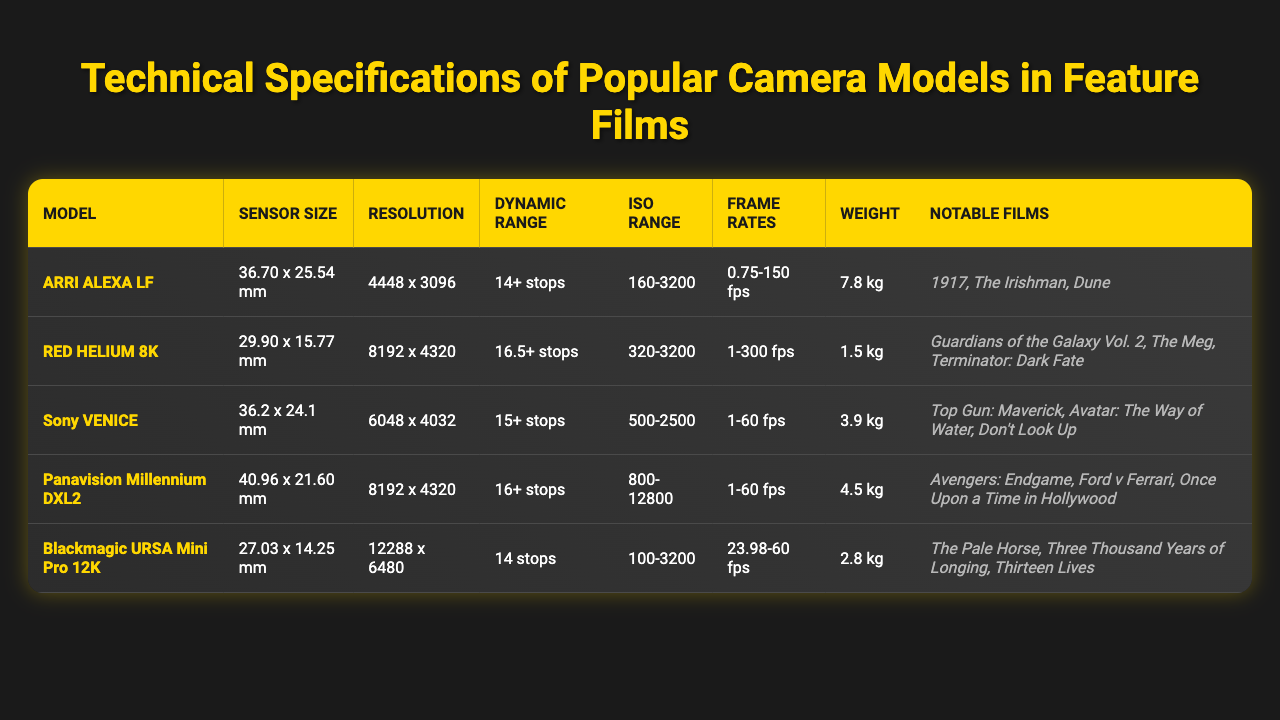What is the sensor size of the ARRI ALEXA LF? The table lists the ARRI ALEXA LF under the "Model" column and its corresponding "Sensor Size" is shown as 36.70 x 25.54 mm.
Answer: 36.70 x 25.54 mm Which camera has the highest resolution? By comparing the "Resolution" values, the RED HELIUM 8K has a resolution of 8192 x 4320, which is higher than all the other listed cameras.
Answer: RED HELIUM 8K What is the ISO range of the Sony VENICE? The table indicates that the Sony VENICE has an "ISO Range" listed as 500-2500, which directly answers the question.
Answer: 500-2500 Which camera has the lowest weight? By checking the "Weight" column, the RED HELIUM 8K shows a weight of 1.5 kg, which is less than the weights of all the other cameras.
Answer: RED HELIUM 8K What is the dynamic range of the Panavision Millennium DXL2? The "Dynamic Range" for the Panavision Millennium DXL2 is given in the table as 16+ stops.
Answer: 16+ stops Is the frame rate of the Blackmagic URSA Mini Pro 12K higher than that of the Sony VENICE? The "Frame Rates" column shows that the Blackmagic URSA Mini Pro 12K supports 23.98-60 fps while the Sony VENICE supports 1-60 fps. The maximum frame rate of the Blackmagic is higher.
Answer: Yes Calculate the average weight of the cameras listed in the table. The weights are 7.8 kg, 1.5 kg, 3.9 kg, 4.5 kg, and 2.8 kg. Summing these gives 20.5 kg. Dividing by 5 (number of cameras) gives an average of 4.1 kg.
Answer: 4.1 kg Which camera has the widest sensor size, and what is its size? The Panavision Millennium DXL2 has the widest sensor size of 40.96 x 21.60 mm, as seen in the "Sensor Size" column of the table.
Answer: Panavision Millennium DXL2, 40.96 x 21.60 mm Are there any cameras listed that have dynamic ranges exceeding 15 stops? The RED HELIUM 8K (16.5+ stops) and the Panavision Millennium DXL2 (16+ stops) both exceed 15 stops in dynamic range according to the table.
Answer: Yes If you were filming a high-action scene in bright light, which camera might be a suitable choice based on ISO range? The ARRI ALEXA LF has an ISO range of 160-3200, which provides good versatility for bright conditions, and it has a high dynamic range.
Answer: ARRI ALEXA LF Which camera is used in the film "Dune"? The notable films corresponding to the ARRI ALEXA LF include "Dune," according to the "Notable Films" column.
Answer: ARRI ALEXA LF 